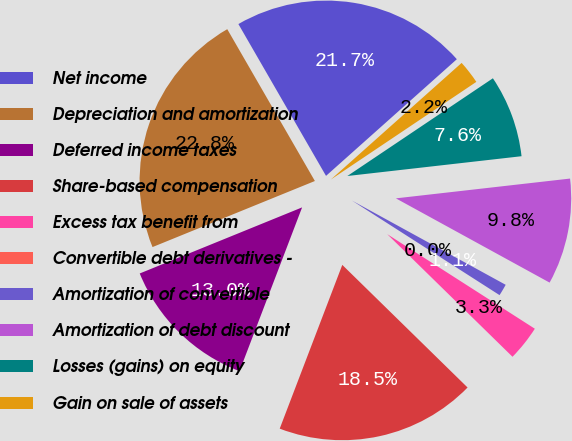<chart> <loc_0><loc_0><loc_500><loc_500><pie_chart><fcel>Net income<fcel>Depreciation and amortization<fcel>Deferred income taxes<fcel>Share-based compensation<fcel>Excess tax benefit from<fcel>Convertible debt derivatives -<fcel>Amortization of convertible<fcel>Amortization of debt discount<fcel>Losses (gains) on equity<fcel>Gain on sale of assets<nl><fcel>21.74%<fcel>22.82%<fcel>13.04%<fcel>18.48%<fcel>3.26%<fcel>0.0%<fcel>1.09%<fcel>9.78%<fcel>7.61%<fcel>2.18%<nl></chart> 